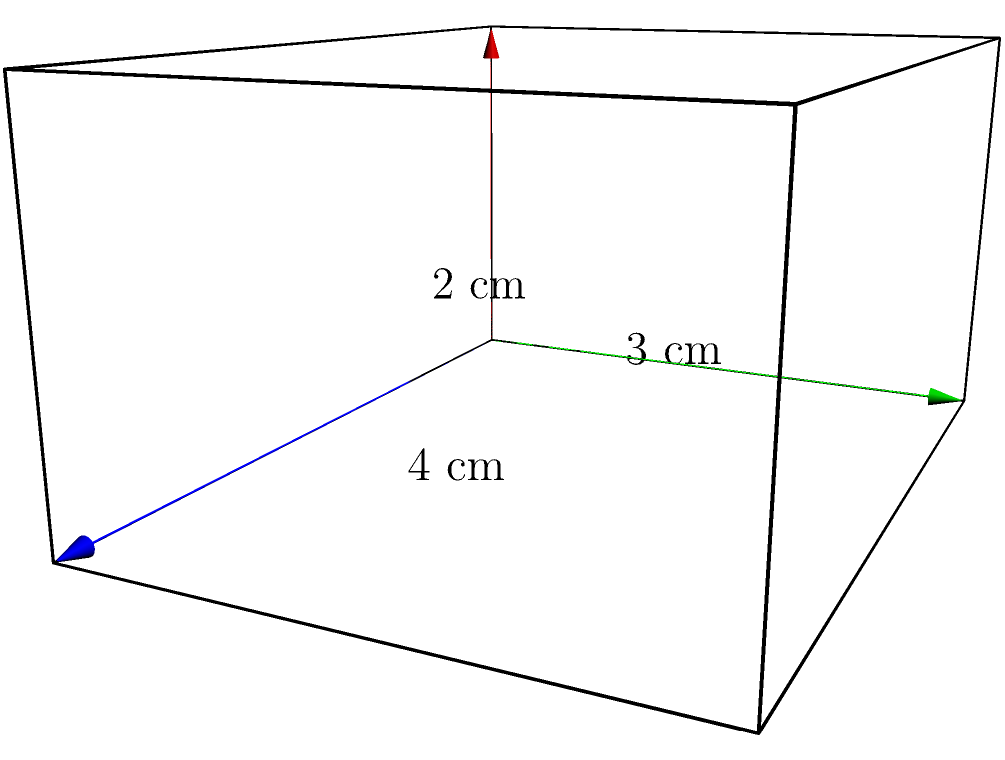Hey Neeraj, remember when we used to build cardboard forts in your backyard? I've got a similar problem now. I'm trying to wrap a gift box for your upcoming birthday. The box is shaped like a rectangular prism with dimensions 4 cm × 3 cm × 2 cm (length × width × height). How much wrapping paper do I need to cover the entire surface of this box? Let's approach this step-by-step, just like we used to plan our fort designs:

1) A rectangular prism has 6 faces: 2 identical faces for each dimension pair.

2) We need to calculate the area of each pair and then sum them up:

   a) Length × Width (top and bottom): 2 × (4 cm × 3 cm) = 2 × 12 cm² = 24 cm²
   b) Length × Height (front and back): 2 × (4 cm × 2 cm) = 2 × 8 cm² = 16 cm²
   c) Width × Height (left and right sides): 2 × (3 cm × 2 cm) = 2 × 6 cm² = 12 cm²

3) Now, let's add all these areas:

   Total Surface Area = 24 cm² + 16 cm² + 12 cm² = 52 cm²

Therefore, you need 52 square centimeters of wrapping paper to cover the entire surface of the gift box.
Answer: 52 cm² 